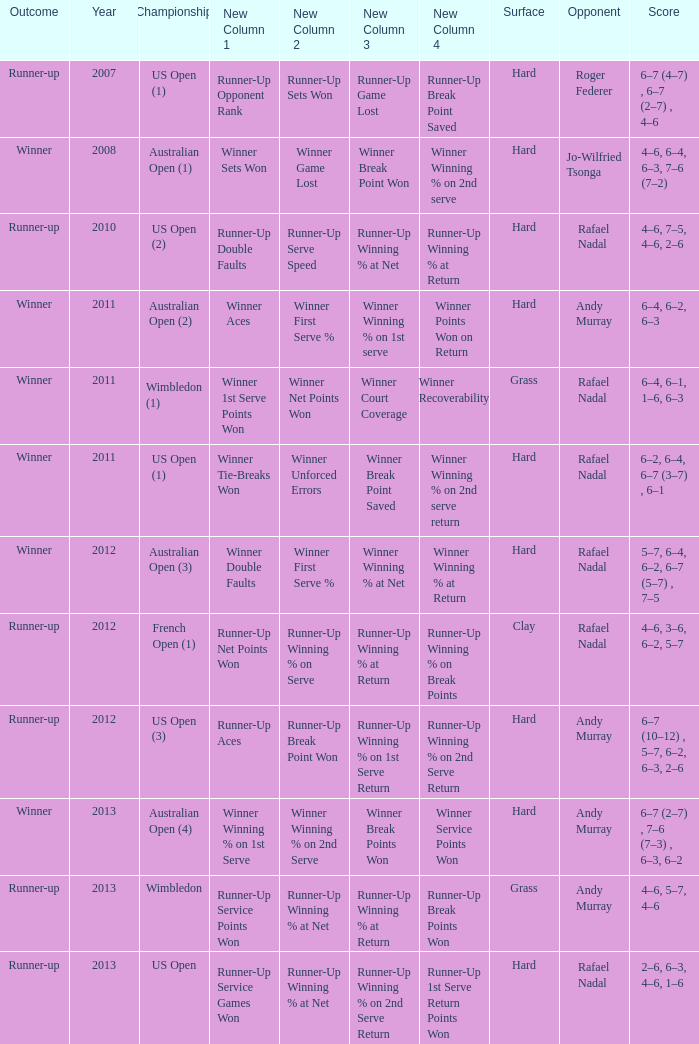What surface was the Australian Open (1) played on? Hard. 